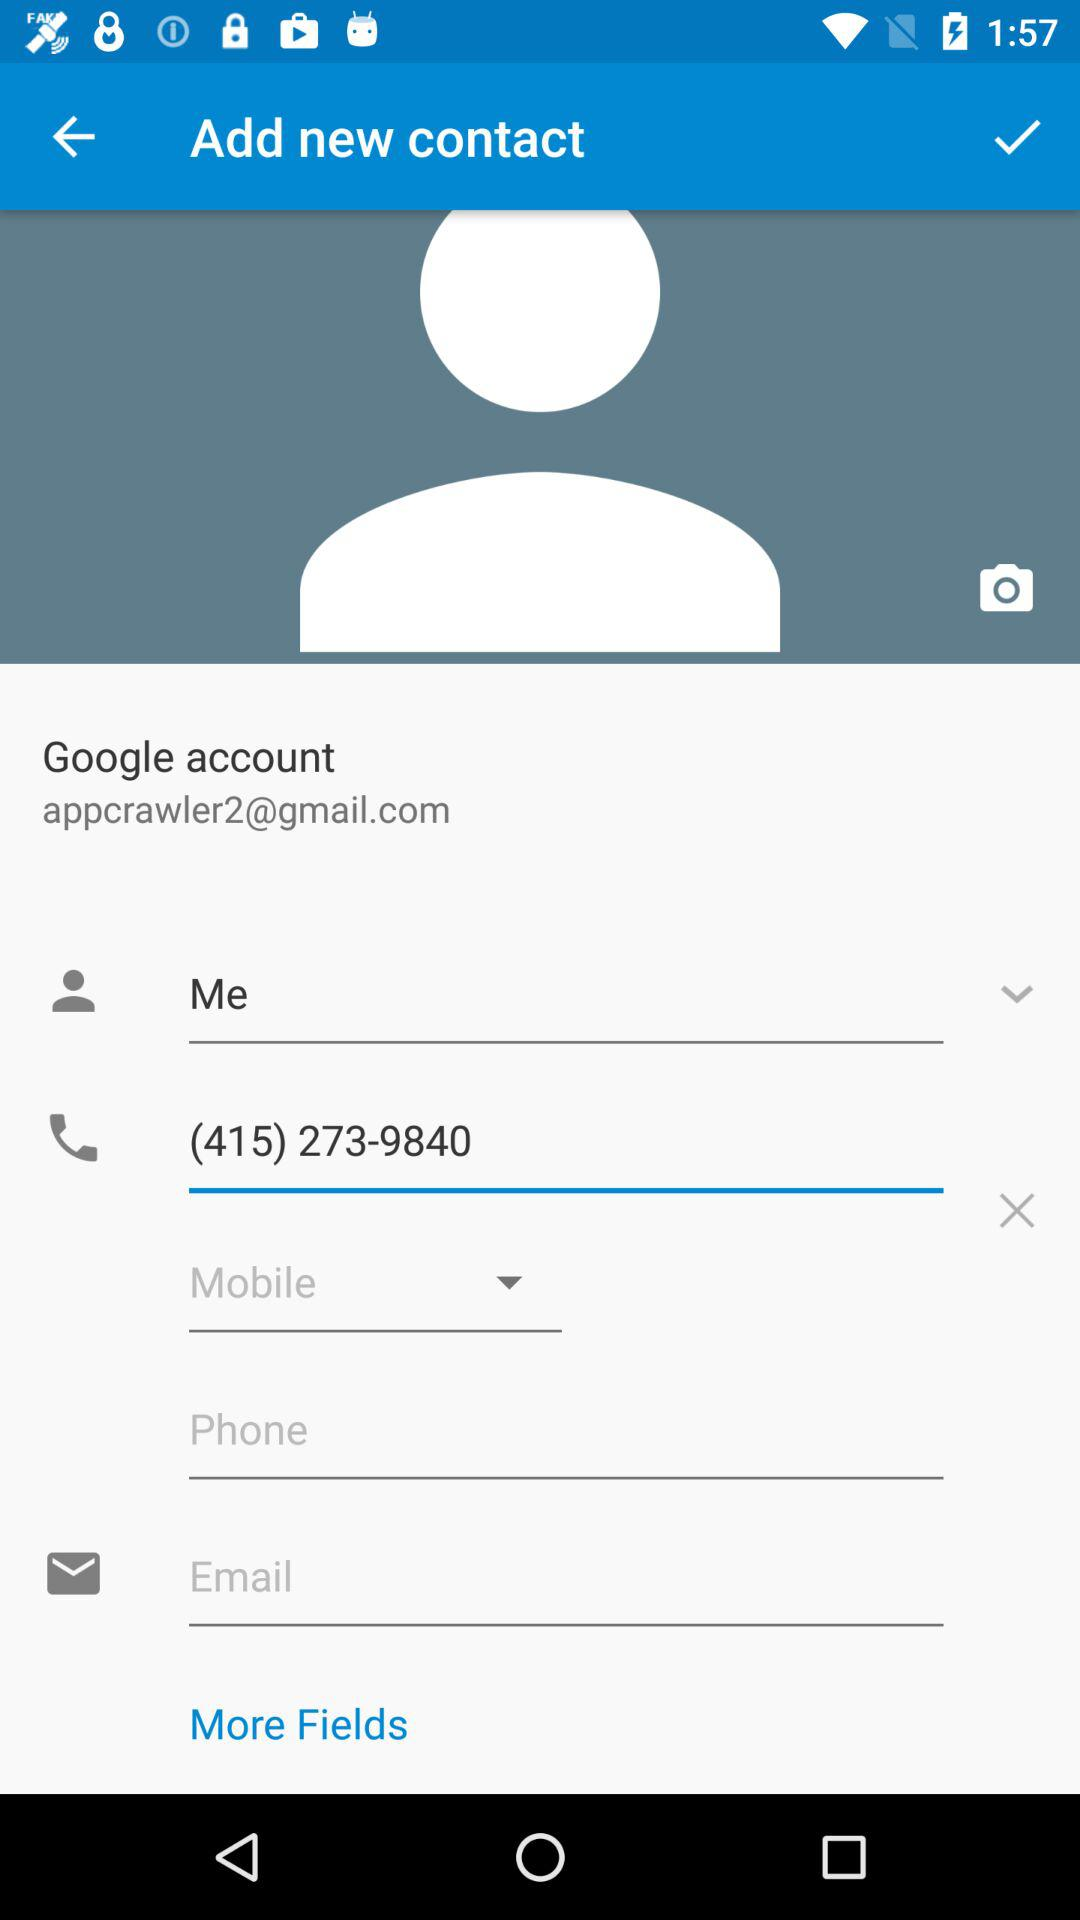When is the user's birthday?
When the provided information is insufficient, respond with <no answer>. <no answer> 